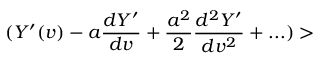<formula> <loc_0><loc_0><loc_500><loc_500>( Y ^ { \prime } ( v ) - a { \frac { d Y ^ { \prime } } { d v } } + { \frac { a ^ { 2 } } { 2 } } { \frac { d ^ { 2 } Y ^ { \prime } } { d v ^ { 2 } } } + \dots ) ></formula> 